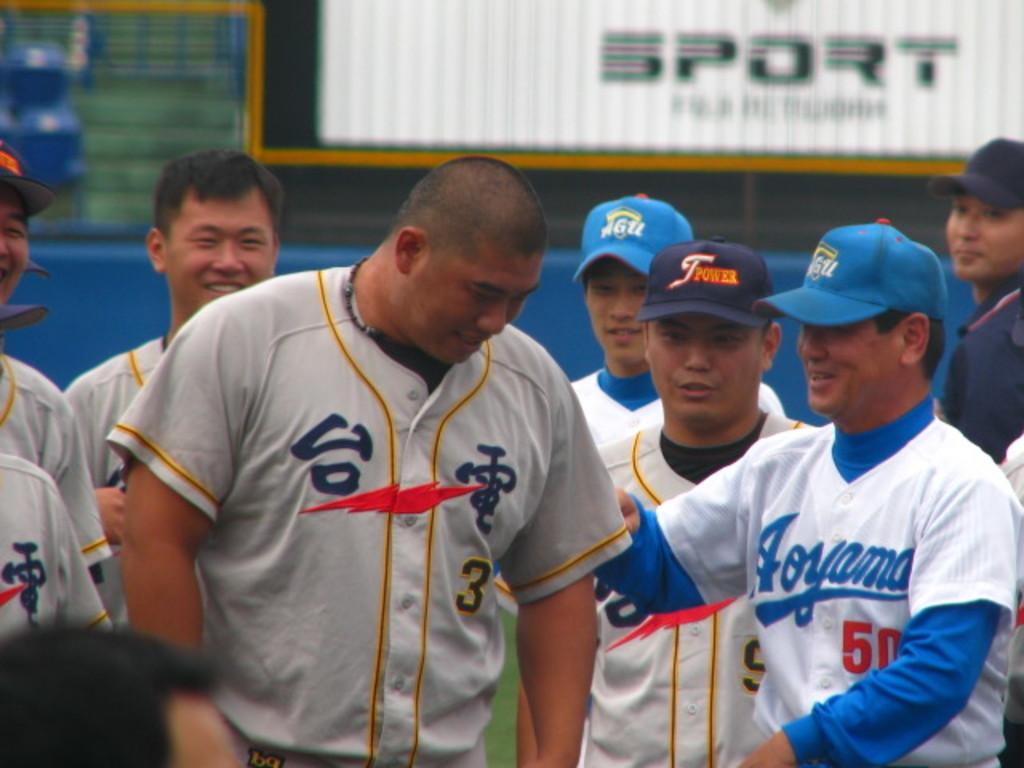How many people are present in the image? There are many people in the image. What type of headwear can be seen on some of the people? Some of the people are wearing caps. Can you describe the background of the image? The background of the image is blurred. What type of structure is visible in the image? There is a wall visible in the image. What type of cream can be seen being applied to the dirt in the image? There is no cream or dirt present in the image; it features many people and a blurred background. 